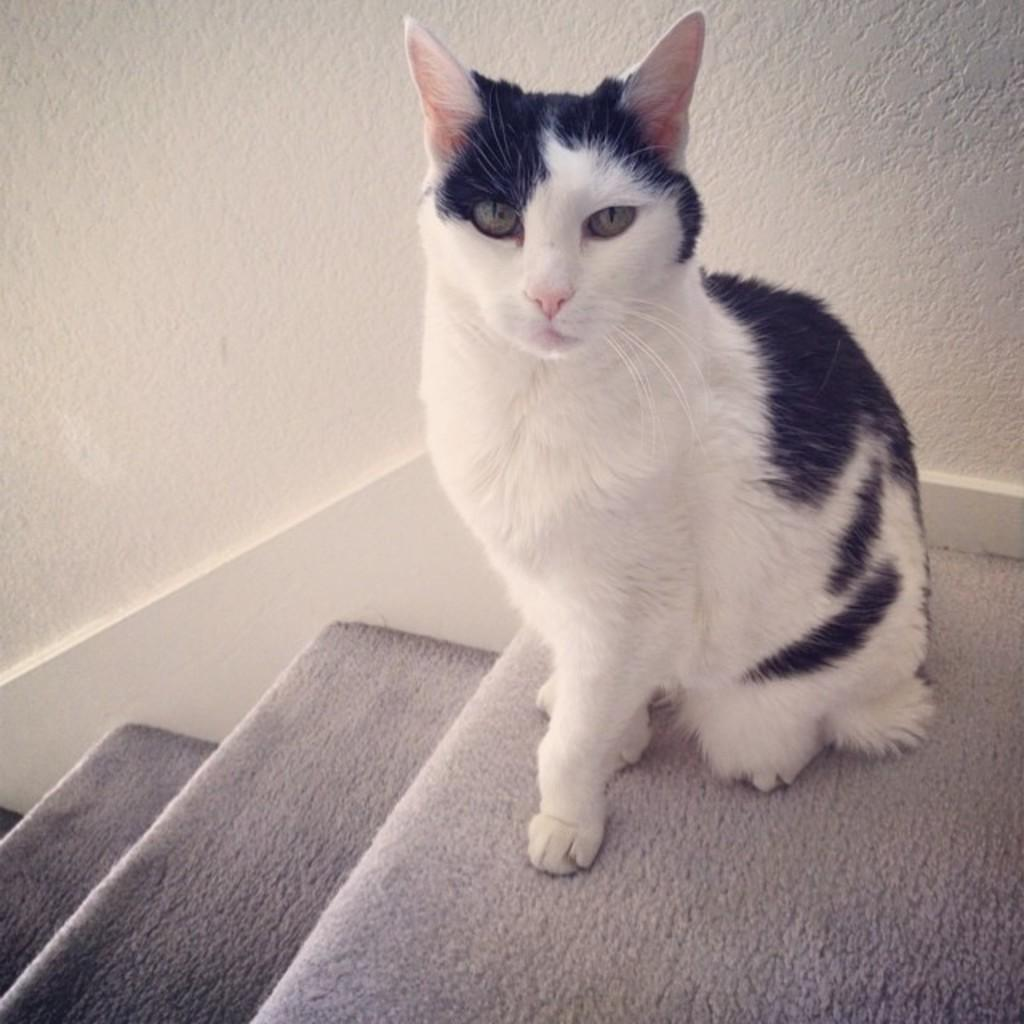What type of animal is in the image? There is a cat in the image. Where is the cat located? The cat is on the floor. What architectural feature can be seen in the image? There are steps in the image. What is visible in the background of the image? There is a wall visible in the background of the image. What type of cup is the cat holding in the image? There is no cup present in the image; the cat is on the floor. What type of approval is the cat seeking in the image? The image does not depict the cat seeking any approval; it is simply a cat on the floor. 